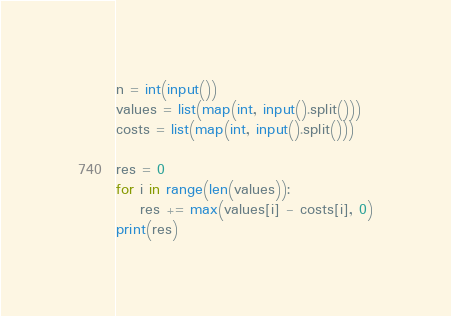Convert code to text. <code><loc_0><loc_0><loc_500><loc_500><_Python_>
n = int(input())
values = list(map(int, input().split()))
costs = list(map(int, input().split()))

res = 0
for i in range(len(values)):
    res += max(values[i] - costs[i], 0)
print(res)</code> 